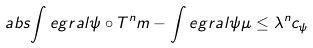<formula> <loc_0><loc_0><loc_500><loc_500>\ a b s { \int e g r a l { \psi \circ T ^ { n } } { m } - \int e g r a l { \psi } { \mu } } \leq \lambda ^ { n } c _ { \psi }</formula> 